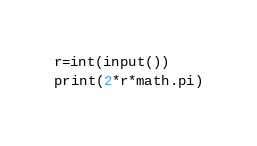<code> <loc_0><loc_0><loc_500><loc_500><_Python_>r=int(input())
print(2*r*math.pi)</code> 